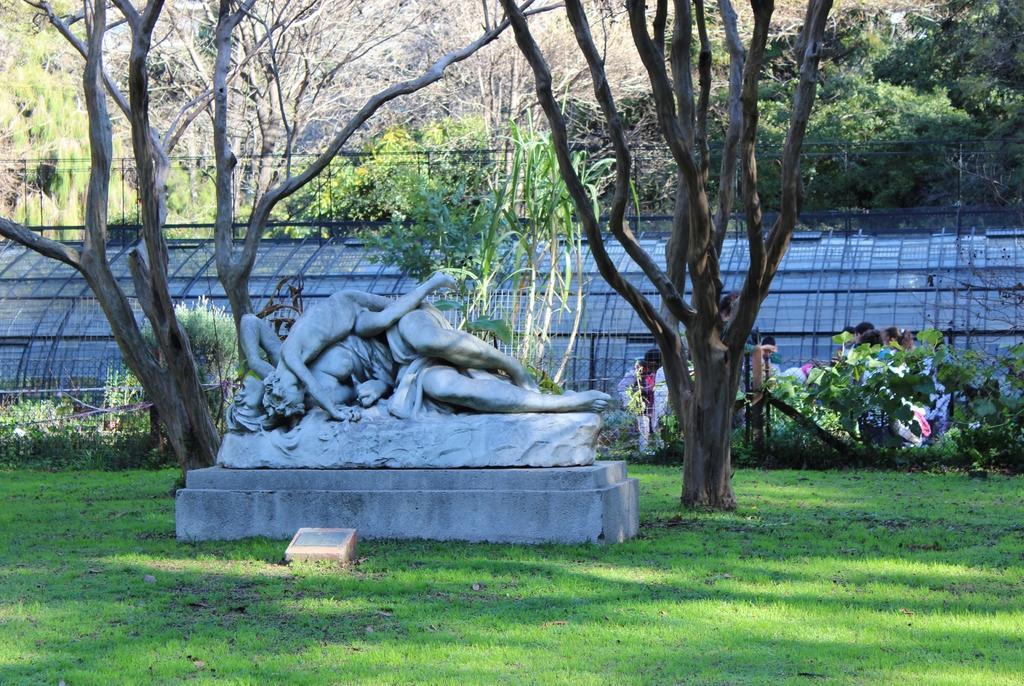How would you summarize this image in a sentence or two? In the center of the image there is a statue. There are trees. At the bottom of the image there is grass. In the background of the image there is fencing. 